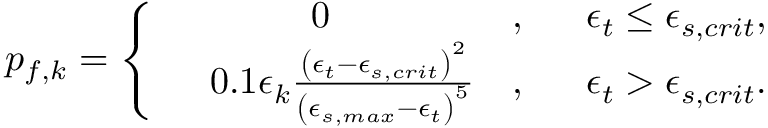Convert formula to latex. <formula><loc_0><loc_0><loc_500><loc_500>\begin{array} { r } { p _ { f , k } = \left \{ \begin{array} { r l r l } & { 0 } & { , } & { \epsilon _ { t } \leq \epsilon _ { s , c r i t } , } \\ & { 0 . 1 \epsilon _ { k } \frac { \left ( \epsilon _ { t } - \epsilon _ { s , c r i t } \right ) ^ { 2 } } { \left ( \epsilon _ { s , \max } - \epsilon _ { t } \right ) ^ { 5 } } } & { , } & { \epsilon _ { t } > \epsilon _ { s , c r i t } . } \end{array} } \end{array}</formula> 